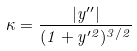<formula> <loc_0><loc_0><loc_500><loc_500>\kappa = \frac { | y ^ { \prime \prime } | } { ( 1 + y ^ { \prime 2 } ) ^ { 3 / 2 } }</formula> 